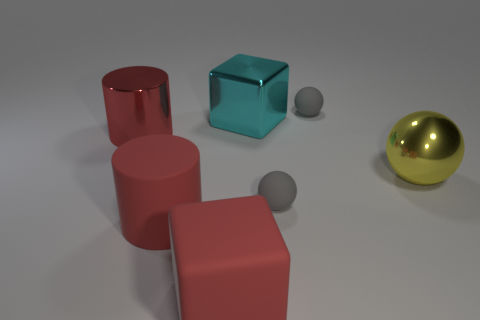Is there anything else that is the same material as the large yellow object?
Your answer should be very brief. Yes. Is the color of the large shiny ball the same as the rubber ball that is in front of the metallic cube?
Your answer should be compact. No. Are there any large yellow balls that are on the left side of the red cylinder on the right side of the large metal cylinder that is to the left of the big metal cube?
Provide a short and direct response. No. Are there fewer cyan cubes in front of the matte cylinder than large cyan spheres?
Make the answer very short. No. What number of other objects are there of the same shape as the cyan metal thing?
Make the answer very short. 1. What number of things are small gray things in front of the big metallic sphere or cyan blocks that are to the left of the large metal ball?
Provide a short and direct response. 2. What is the size of the rubber thing that is both on the right side of the large cyan metal block and in front of the big ball?
Ensure brevity in your answer.  Small. There is a gray rubber thing in front of the cyan metallic object; is its shape the same as the yellow shiny thing?
Give a very brief answer. Yes. What is the size of the red object left of the red matte object behind the block that is left of the cyan metallic cube?
Offer a very short reply. Large. The matte block that is the same color as the shiny cylinder is what size?
Your answer should be very brief. Large. 